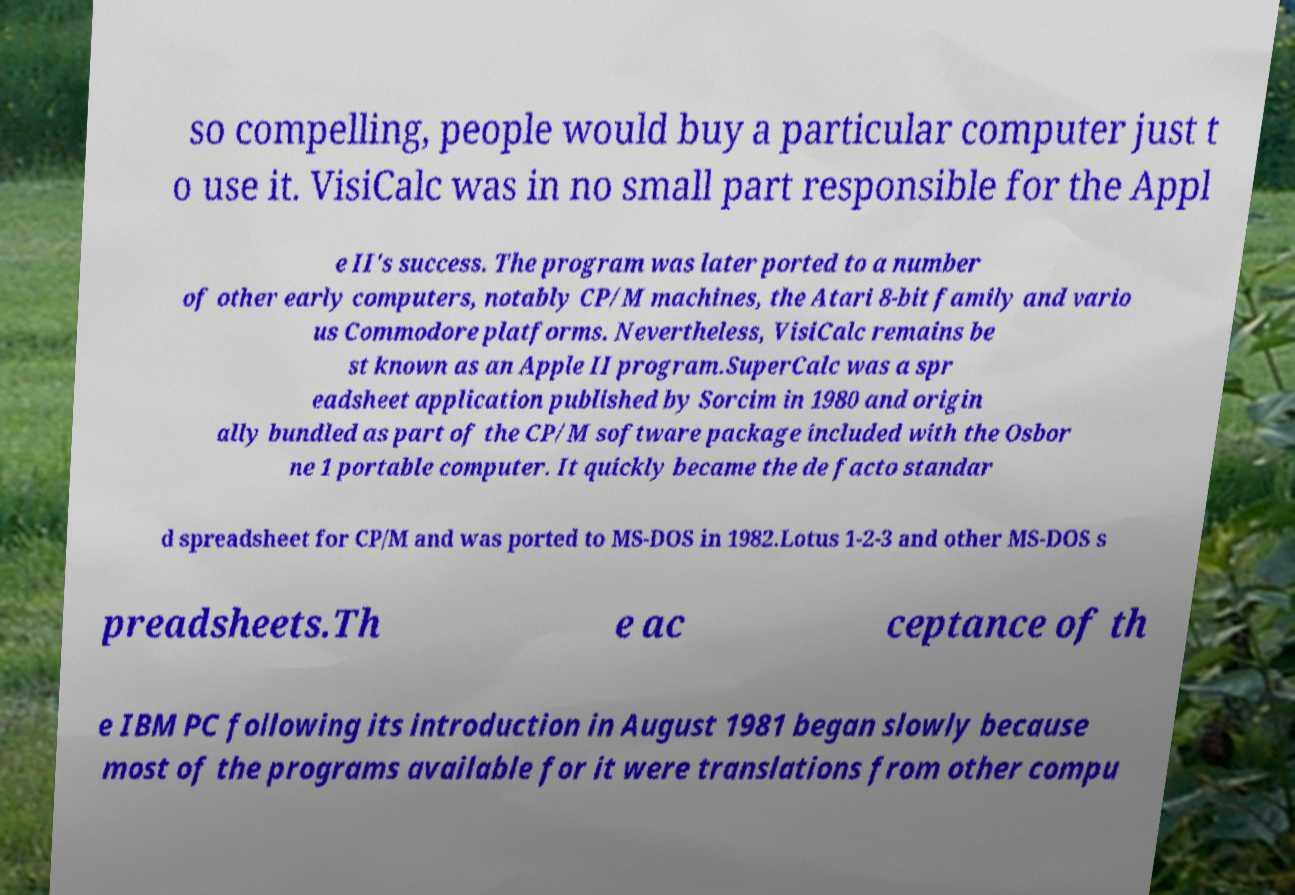I need the written content from this picture converted into text. Can you do that? so compelling, people would buy a particular computer just t o use it. VisiCalc was in no small part responsible for the Appl e II's success. The program was later ported to a number of other early computers, notably CP/M machines, the Atari 8-bit family and vario us Commodore platforms. Nevertheless, VisiCalc remains be st known as an Apple II program.SuperCalc was a spr eadsheet application published by Sorcim in 1980 and origin ally bundled as part of the CP/M software package included with the Osbor ne 1 portable computer. It quickly became the de facto standar d spreadsheet for CP/M and was ported to MS-DOS in 1982.Lotus 1-2-3 and other MS-DOS s preadsheets.Th e ac ceptance of th e IBM PC following its introduction in August 1981 began slowly because most of the programs available for it were translations from other compu 